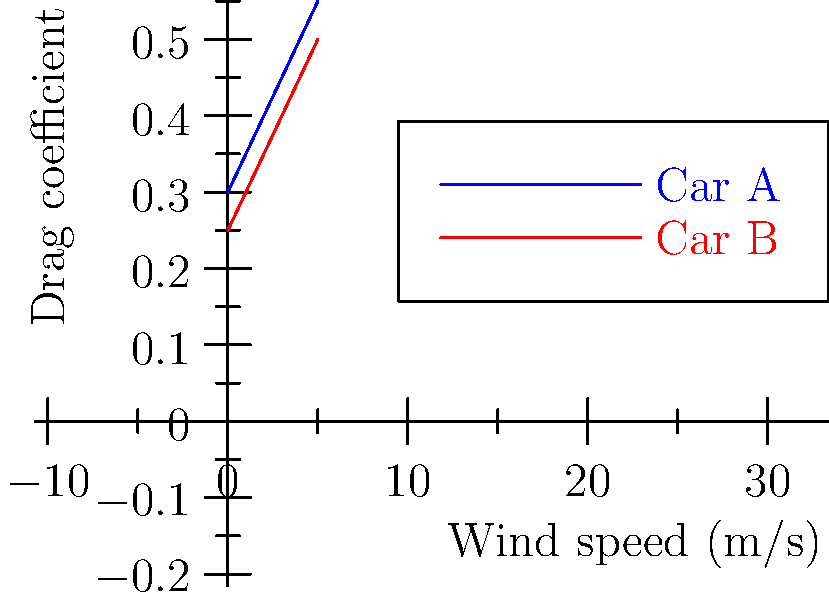Based on the wind tunnel simulation results shown in the graph, which Formula 1 car design demonstrates superior aerodynamic efficiency, and how might this impact the performance of a talented young driver in various racing conditions? To answer this question, we need to analyze the graph and understand the relationship between drag coefficient and aerodynamic efficiency:

1. The graph shows the drag coefficient of two different F1 car designs (Car A and Car B) at various wind speeds.

2. A lower drag coefficient indicates better aerodynamic efficiency, as it means the car experiences less air resistance.

3. Comparing the two lines:
   - Car B (red line) consistently has a lower drag coefficient across all wind speeds.
   - Car A (blue line) has a higher drag coefficient at all measured wind speeds.

4. The difference in drag coefficients between the two cars remains relatively constant as wind speed increases.

5. Impact on a talented young driver's performance:
   a) Straight-line speed: Car B would likely achieve higher top speeds due to reduced air resistance.
   b) Fuel efficiency: Lower drag means less energy is required to maintain speed, potentially allowing for fewer pit stops or more aggressive race strategies.
   c) Cornering: While not directly shown in the graph, a more aerodynamically efficient car often generates more downforce, which could improve cornering speeds and stability.
   d) Overtaking: The aerodynamic advantage of Car B could provide more opportunities for overtaking, especially on long straights.
   e) Adaptability: The consistent advantage across wind speeds suggests Car B would perform better in various weather conditions and on different track layouts.

6. For a young driver, Car B's superior aerodynamics could:
   - Boost confidence due to improved overall performance
   - Allow for more focus on driving technique rather than compensating for car deficiencies
   - Potentially lead to better race results, which is crucial for career advancement in F1
Answer: Car B; lower drag coefficient across all wind speeds, offering advantages in speed, efficiency, and overall performance for a young driver. 